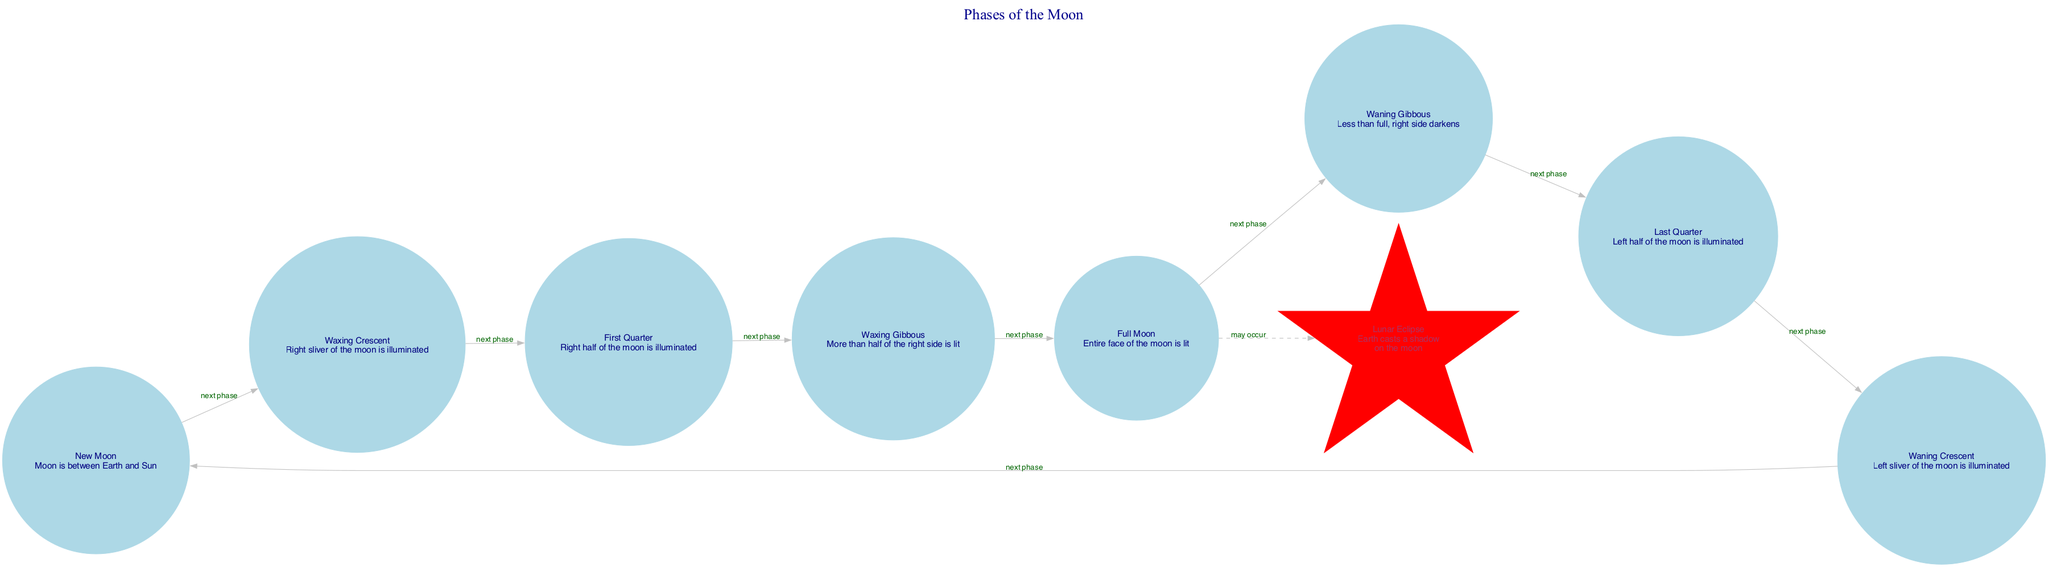What are the phases of the Moon? The diagram lists eight phases of the Moon: New Moon, Waxing Crescent, First Quarter, Waxing Gibbous, Full Moon, Waning Gibbous, Last Quarter, and Waning Crescent.
Answer: New Moon, Waxing Crescent, First Quarter, Waxing Gibbous, Full Moon, Waning Gibbous, Last Quarter, Waning Crescent What occurs during a lunar eclipse? The diagram shows that in a lunar eclipse, Earth casts a shadow on the moon, indicating that this event involves the positions of Earth and the Moon relative to the Sun.
Answer: Earth casts a shadow on the moon What is the next phase after the full Moon? From the diagram, the flow indicates that the phase that follows full Moon is waning gibbous, making it a direct successor in the sequence.
Answer: Waning Gibbous How many edges are there in the diagram? By counting the lines that connect the nodes, the diagram has eight edges which represent transitions between the Moon's phases.
Answer: Eight Which phase is illustrated with a star shape? The unique differentiation in the diagram indicates that the lunar eclipse is represented as a star, distinguishing it from the other circular nodes.
Answer: Lunar Eclipse What phase follows the waxing crescent phase? In tracing from the waxing crescent node, the subsequent phase identified in the diagram is the first quarter, which directly follows it in the sequence.
Answer: First Quarter What phase is the last one before the new moon? The diagram delineates that right before the new moon phase, the waning crescent occurs, as it is the last phase in the lunar cycle before returning to new moon.
Answer: Waning Crescent In what phase is the left half illuminated? The last quarter is specifically described in the diagram as the phase where the left half of the moon is illuminated, which forms part of the sequence of phases.
Answer: Last Quarter How many total phases of the Moon are depicted in the diagram? By counting each distinct phase listed in the nodes section, there are a total of eight different phases of the Moon represented in the diagram.
Answer: Eight 